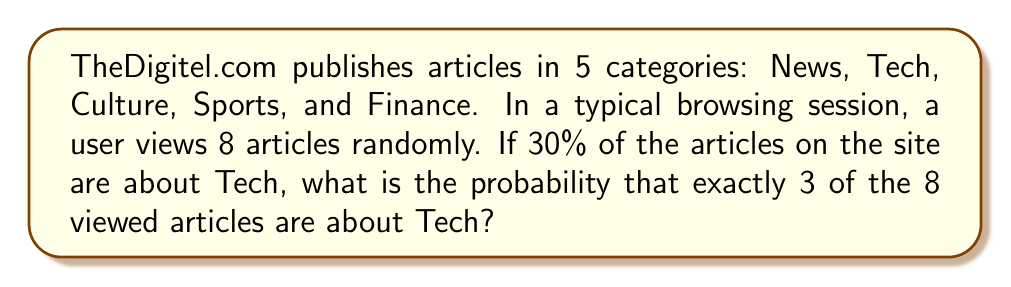Show me your answer to this math problem. Let's approach this step-by-step using the binomial probability formula:

1) This scenario follows a binomial distribution because:
   - There are a fixed number of trials (8 article views)
   - Each trial has two possible outcomes (Tech or not Tech)
   - The probability of success (viewing a Tech article) is constant
   - The trials are independent

2) The binomial probability formula is:

   $$P(X = k) = \binom{n}{k} p^k (1-p)^{n-k}$$

   Where:
   $n$ = number of trials
   $k$ = number of successes
   $p$ = probability of success on each trial

3) In this case:
   $n = 8$ (total articles viewed)
   $k = 3$ (Tech articles we want to see)
   $p = 0.30$ (30% of articles are Tech)

4) Let's calculate each part:

   $\binom{8}{3} = \frac{8!}{3!(8-3)!} = \frac{8!}{3!5!} = 56$

   $0.30^3 = 0.027$

   $(1-0.30)^{8-3} = 0.70^5 = 0.16807$

5) Now, let's put it all together:

   $$P(X = 3) = 56 \times 0.027 \times 0.16807 = 0.2541$$

6) Therefore, the probability is approximately 0.2541 or 25.41%.
Answer: 0.2541 